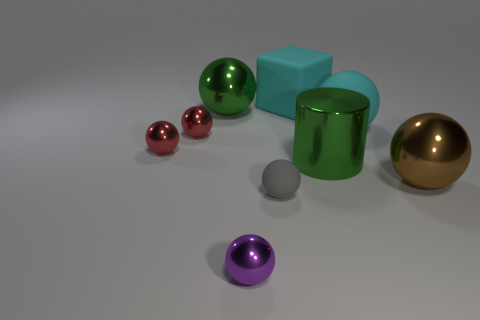Does the green object that is left of the cyan cube have the same material as the tiny purple ball left of the gray sphere?
Your answer should be very brief. Yes. What is the color of the thing behind the big ball to the left of the big cyan object behind the large green metal sphere?
Make the answer very short. Cyan. How many other objects are there of the same shape as the small gray thing?
Your answer should be compact. 6. Does the big matte ball have the same color as the large cube?
Ensure brevity in your answer.  Yes. What number of things are big blue rubber objects or big spheres that are on the left side of the purple object?
Give a very brief answer. 1. Are there any matte objects that have the same size as the cyan ball?
Keep it short and to the point. Yes. Do the cyan cube and the gray object have the same material?
Keep it short and to the point. Yes. What number of objects are either big brown spheres or purple metal spheres?
Your response must be concise. 2. What size is the green shiny cylinder?
Give a very brief answer. Large. Is the number of big cyan spheres less than the number of tiny purple rubber objects?
Ensure brevity in your answer.  No. 